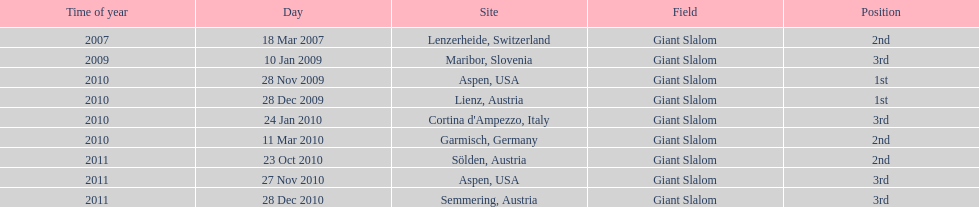Could you parse the entire table? {'header': ['Time of year', 'Day', 'Site', 'Field', 'Position'], 'rows': [['2007', '18 Mar 2007', 'Lenzerheide, Switzerland', 'Giant Slalom', '2nd'], ['2009', '10 Jan 2009', 'Maribor, Slovenia', 'Giant Slalom', '3rd'], ['2010', '28 Nov 2009', 'Aspen, USA', 'Giant Slalom', '1st'], ['2010', '28 Dec 2009', 'Lienz, Austria', 'Giant Slalom', '1st'], ['2010', '24 Jan 2010', "Cortina d'Ampezzo, Italy", 'Giant Slalom', '3rd'], ['2010', '11 Mar 2010', 'Garmisch, Germany', 'Giant Slalom', '2nd'], ['2011', '23 Oct 2010', 'Sölden, Austria', 'Giant Slalom', '2nd'], ['2011', '27 Nov 2010', 'Aspen, USA', 'Giant Slalom', '3rd'], ['2011', '28 Dec 2010', 'Semmering, Austria', 'Giant Slalom', '3rd']]} Where was her first win? Aspen, USA. 